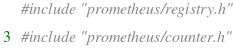<code> <loc_0><loc_0><loc_500><loc_500><_C++_>#include "prometheus/registry.h"

#include "prometheus/counter.h"</code> 